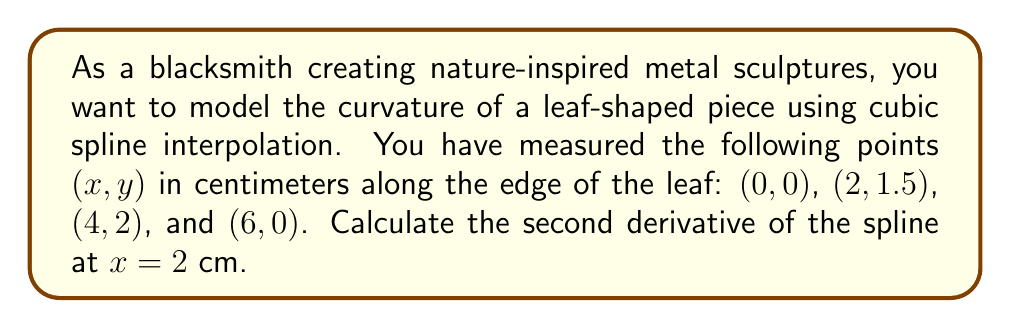Could you help me with this problem? To solve this problem, we'll use cubic spline interpolation and follow these steps:

1) For n+1 points, we need n cubic polynomials. In this case, we have 4 points, so we need 3 cubic polynomials.

2) The general form of a cubic spline is:
   $$S_i(x) = a_i + b_i(x-x_i) + c_i(x-x_i)^2 + d_i(x-x_i)^3$$
   where i = 0, 1, 2

3) We need to solve for the coefficients $c_i$. The others can be derived from these.

4) Set up the tridiagonal system:
   $$\begin{bmatrix}
   2(h_0+h_1) & h_1 & 0 \\
   h_1 & 2(h_1+h_2) & h_2 \\
   0 & h_2 & 2(h_2+h_3)
   \end{bmatrix}
   \begin{bmatrix}
   c_0 \\ c_1 \\ c_2
   \end{bmatrix} = 
   \begin{bmatrix}
   3(\frac{f_2-f_1}{h_1} - \frac{f_1-f_0}{h_0}) \\
   3(\frac{f_3-f_2}{h_2} - \frac{f_2-f_1}{h_1}) \\
   3(\frac{f_4-f_3}{h_3} - \frac{f_3-f_2}{h_2})
   \end{bmatrix}$$

   Where $h_i = x_{i+1} - x_i$ and $f_i = y_i$

5) Solve this system:
   $$\begin{bmatrix}
   4 & 2 & 0 \\
   2 & 4 & 2 \\
   0 & 2 & 4
   \end{bmatrix}
   \begin{bmatrix}
   c_0 \\ c_1 \\ c_2
   \end{bmatrix} = 
   \begin{bmatrix}
   -0.75 \\ -1.5 \\ -3
   \end{bmatrix}$$

6) The solution is:
   $$c_0 = -0.28125, c_1 = -0.1875, c_2 = -0.65625$$

7) For the spline containing x = 2, we need $S_0(x)$. Its second derivative is:
   $$S_0''(x) = 2c_0 + 6d_0(x-x_0)$$

8) We can find $d_0$ using:
   $$d_0 = \frac{c_1 - c_0}{3h_0} = \frac{-0.1875 - (-0.28125)}{3(2)} = 0.015625$$

9) Now we can calculate $S_0''(2)$:
   $$S_0''(2) = 2(-0.28125) + 6(0.015625)(2-0) = -0.375$$
Answer: The second derivative of the spline at x = 2 cm is $-0.375$ cm$^{-1}$. 